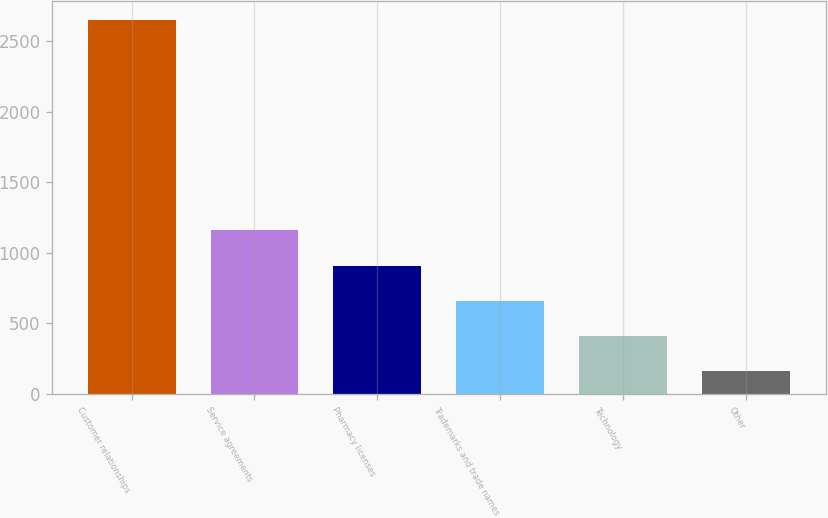Convert chart. <chart><loc_0><loc_0><loc_500><loc_500><bar_chart><fcel>Customer relationships<fcel>Service agreements<fcel>Pharmacy licenses<fcel>Trademarks and trade names<fcel>Technology<fcel>Other<nl><fcel>2652<fcel>1158.6<fcel>909.7<fcel>660.8<fcel>411.9<fcel>163<nl></chart> 